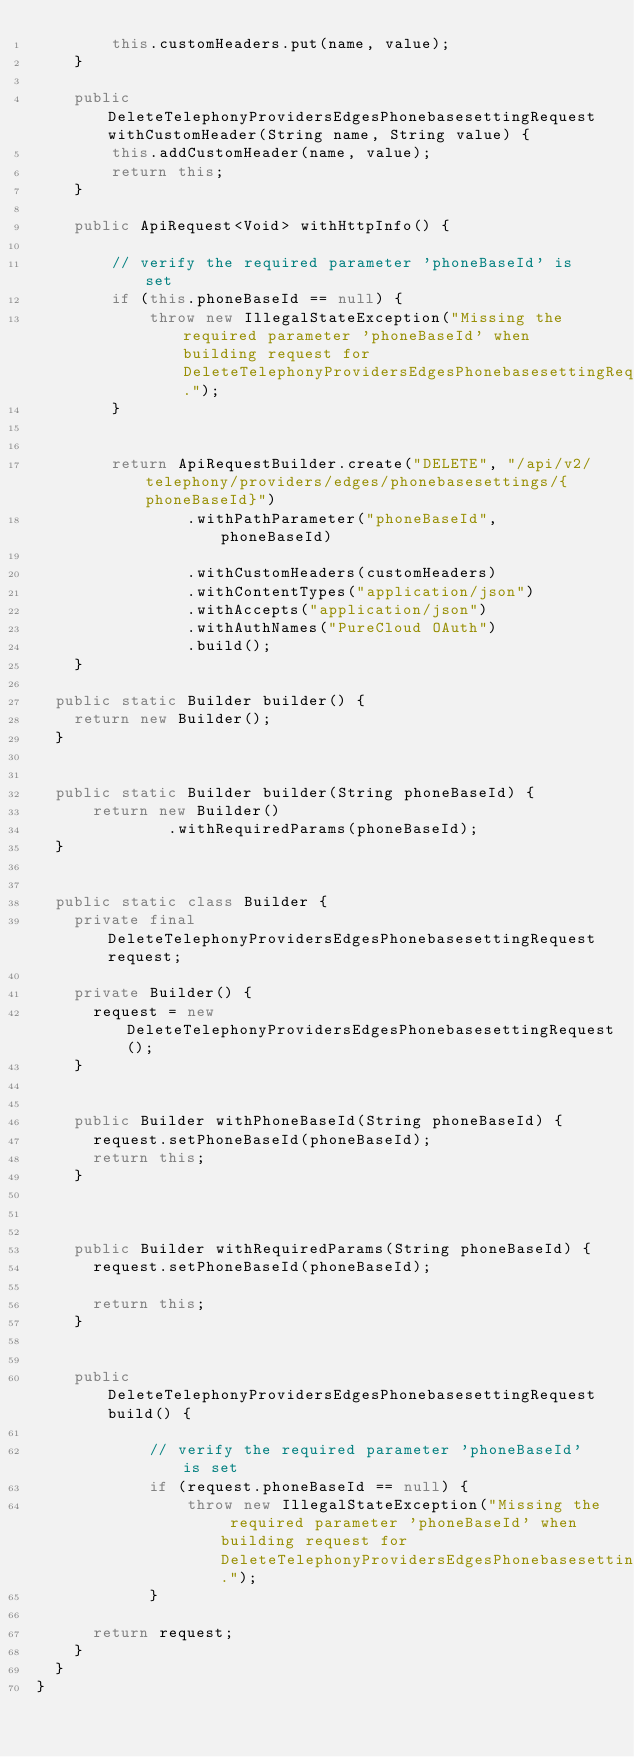<code> <loc_0><loc_0><loc_500><loc_500><_Java_>        this.customHeaders.put(name, value);
    }

    public DeleteTelephonyProvidersEdgesPhonebasesettingRequest withCustomHeader(String name, String value) {
        this.addCustomHeader(name, value);
        return this;
    }

    public ApiRequest<Void> withHttpInfo() {
        
        // verify the required parameter 'phoneBaseId' is set
        if (this.phoneBaseId == null) {
            throw new IllegalStateException("Missing the required parameter 'phoneBaseId' when building request for DeleteTelephonyProvidersEdgesPhonebasesettingRequest.");
        }
        

        return ApiRequestBuilder.create("DELETE", "/api/v2/telephony/providers/edges/phonebasesettings/{phoneBaseId}")
                .withPathParameter("phoneBaseId", phoneBaseId)
        
                .withCustomHeaders(customHeaders)
                .withContentTypes("application/json")
                .withAccepts("application/json")
                .withAuthNames("PureCloud OAuth")
                .build();
    }

	public static Builder builder() {
		return new Builder();
	}

	
	public static Builder builder(String phoneBaseId) {
	    return new Builder()
	            .withRequiredParams(phoneBaseId);
	}
	

	public static class Builder {
		private final DeleteTelephonyProvidersEdgesPhonebasesettingRequest request;

		private Builder() {
			request = new DeleteTelephonyProvidersEdgesPhonebasesettingRequest();
		}

		
		public Builder withPhoneBaseId(String phoneBaseId) {
			request.setPhoneBaseId(phoneBaseId);
			return this;
		}
		

		
		public Builder withRequiredParams(String phoneBaseId) {
			request.setPhoneBaseId(phoneBaseId);
			
			return this;
		}
		

		public DeleteTelephonyProvidersEdgesPhonebasesettingRequest build() {
            
            // verify the required parameter 'phoneBaseId' is set
            if (request.phoneBaseId == null) {
                throw new IllegalStateException("Missing the required parameter 'phoneBaseId' when building request for DeleteTelephonyProvidersEdgesPhonebasesettingRequest.");
            }
            
			return request;
		}
	}
}
</code> 